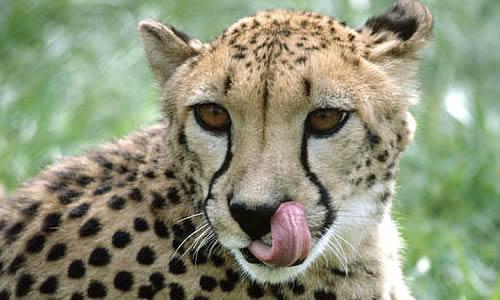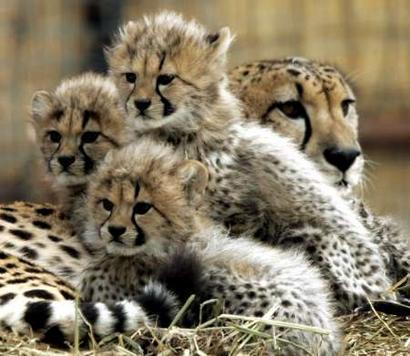The first image is the image on the left, the second image is the image on the right. Assess this claim about the two images: "A total of five cheetahs are shown between the two images.". Correct or not? Answer yes or no. Yes. 